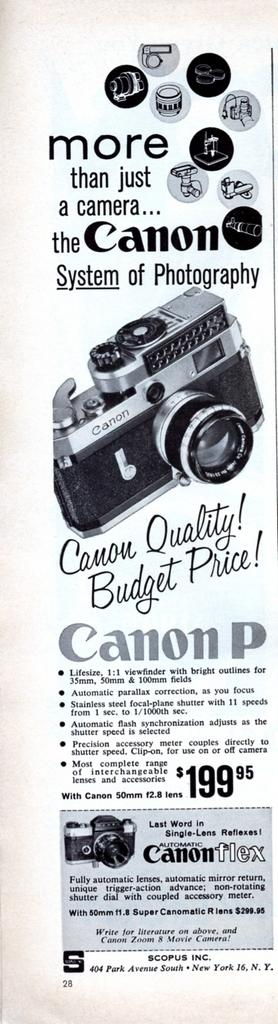What can be seen in the foreground of the poster? In the foreground of the poster, there is text and cameras. Can you describe the text in the foreground of the poster? Unfortunately, the specific details of the text cannot be determined from the provided facts. What type of cameras are depicted in the foreground of the poster? The facts do not specify the type of cameras in the foreground of the poster. Where is the garden located in the poster? There is no garden present in the poster; it features text and cameras in the foreground. How many books are stacked on the table in the poster? There is no table or books present in the poster; it only features text and cameras in the foreground. 